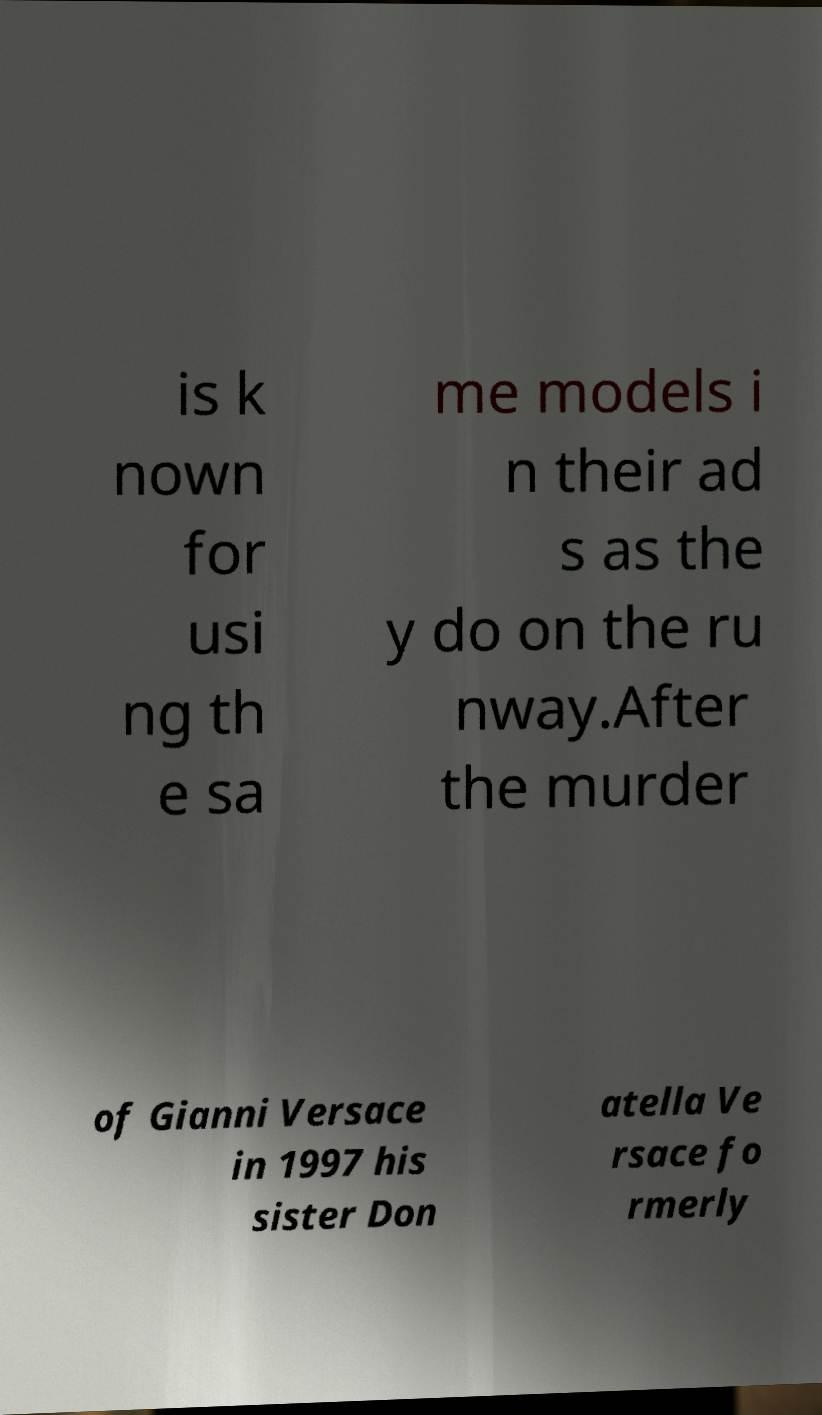Can you accurately transcribe the text from the provided image for me? is k nown for usi ng th e sa me models i n their ad s as the y do on the ru nway.After the murder of Gianni Versace in 1997 his sister Don atella Ve rsace fo rmerly 